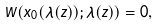Convert formula to latex. <formula><loc_0><loc_0><loc_500><loc_500>W ( x _ { 0 } ( \bar { \lambda } ( z ) ) ; \bar { \lambda } ( z ) ) = 0 ,</formula> 